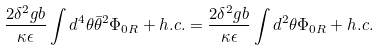<formula> <loc_0><loc_0><loc_500><loc_500>\frac { 2 \delta ^ { 2 } g b } { \kappa \epsilon } \int d ^ { 4 } \theta \bar { \theta } ^ { 2 } \Phi _ { 0 R } + h . c . = \frac { 2 \delta ^ { 2 } g b } { \kappa \epsilon } \int d ^ { 2 } \theta \Phi _ { 0 R } + h . c .</formula> 